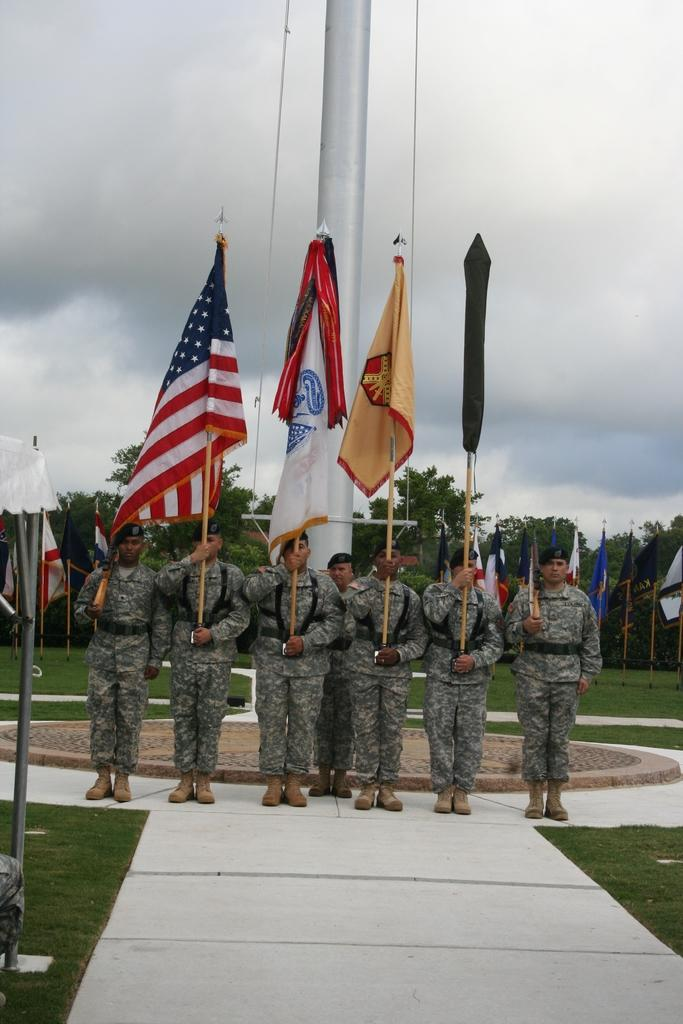What are the people in the image wearing? The people in the image are wearing army dresses. What are the people holding in the image? The people are holding flags in the image. What type of terrain is visible in the image? There is grass in the image, which suggests a grassy terrain. What else can be seen in the background of the image? There are trees and the sky visible in the image. What is the condition of the sky in the image? Clouds are present in the sky, indicating a partly cloudy day. What type of creature can be seen playing near the seashore in the image? There is no seashore or creature present in the image; it features people wearing army dresses and holding flags in a grassy terrain with trees and a partly cloudy sky. 